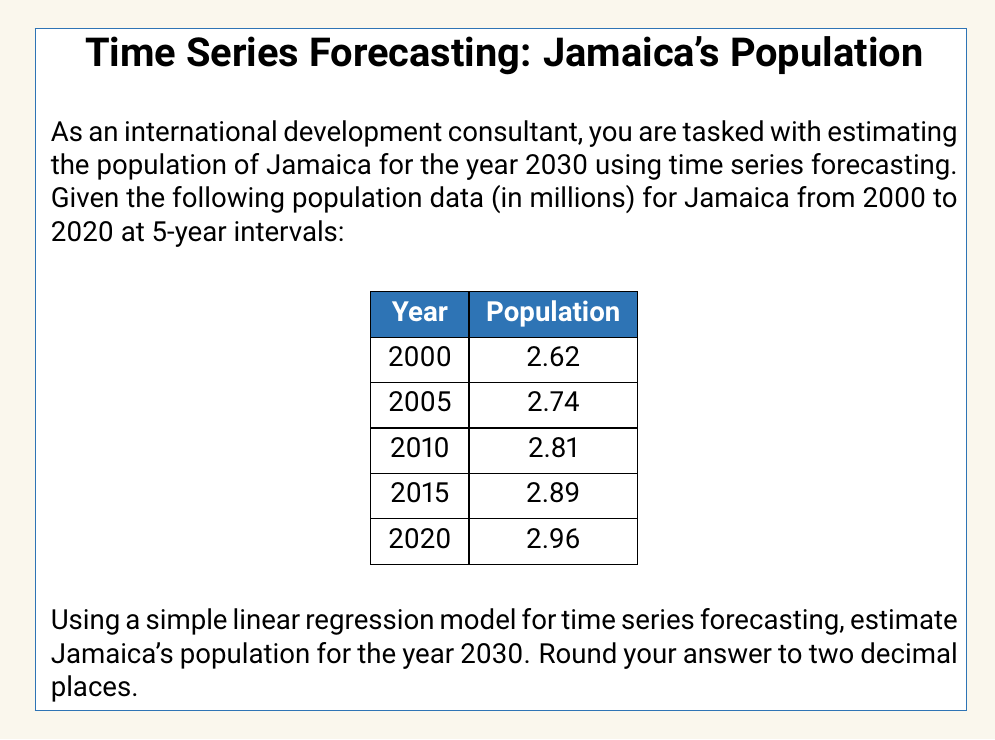What is the answer to this math problem? To estimate the population of Jamaica for 2030 using simple linear regression, we'll follow these steps:

1. Assign numerical values to the years, with 2000 as 0, 2005 as 1, and so on.
2. Calculate the means of x (time) and y (population).
3. Calculate the slope (b) of the regression line.
4. Calculate the y-intercept (a) of the regression line.
5. Use the equation to predict the population for 2030.

Step 1: Assign numerical values to years
x: 0, 1, 2, 3, 4
y: 2.62, 2.74, 2.81, 2.89, 2.96

Step 2: Calculate means
$\bar{x} = \frac{0 + 1 + 2 + 3 + 4}{5} = 2$
$\bar{y} = \frac{2.62 + 2.74 + 2.81 + 2.89 + 2.96}{5} = 2.804$

Step 3: Calculate the slope (b)
$$b = \frac{\sum(x - \bar{x})(y - \bar{y})}{\sum(x - \bar{x})^2}$$

$\sum(x - \bar{x})(y - \bar{y}) = (-2)(2.62 - 2.804) + (-1)(2.74 - 2.804) + (0)(2.81 - 2.804) + (1)(2.89 - 2.804) + (2)(2.96 - 2.804) = 0.34$

$\sum(x - \bar{x})^2 = (-2)^2 + (-1)^2 + (0)^2 + (1)^2 + (2)^2 = 10$

$b = \frac{0.34}{10} = 0.034$

Step 4: Calculate the y-intercept (a)
$a = \bar{y} - b\bar{x} = 2.804 - (0.034)(2) = 2.736$

Step 5: Use the equation to predict the population for 2030
The equation of the regression line is:
$y = a + bx$

For 2030, x = 6 (as 2030 is 6 intervals from 2000)

$y = 2.736 + (0.034)(6) = 2.940$
Answer: The estimated population of Jamaica for the year 2030 using simple linear regression is 2.94 million. 